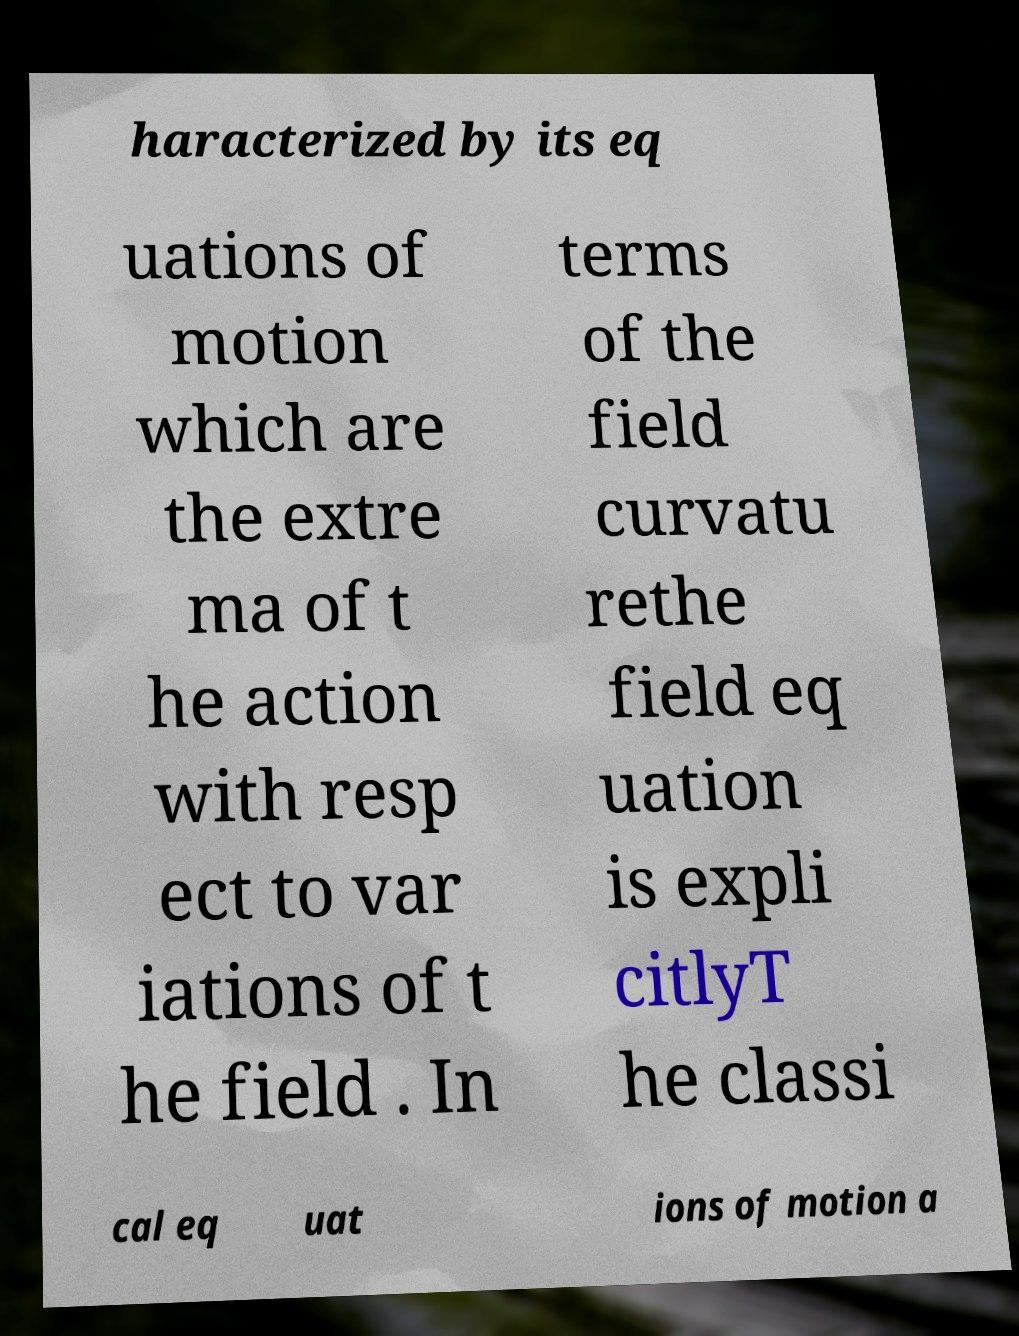Please read and relay the text visible in this image. What does it say? haracterized by its eq uations of motion which are the extre ma of t he action with resp ect to var iations of t he field . In terms of the field curvatu rethe field eq uation is expli citlyT he classi cal eq uat ions of motion a 